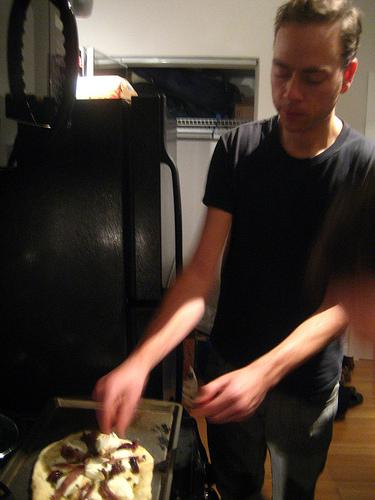Identify the color of the fridge and where it is located in relation to the man. The fridge is black and it is located besides the man. Can you list three distinct features of the man's face? The man has a visible nose, mouth, and eyebrows. Explain the position and color of the tray. The tray is grey in color and is located in the stove. Analyze the interaction between the man and the objects around him. The man is actively preparing food, possibly using the stove, with a fridge and other objects nearby, suggesting he is engaging with his kitchen environment. What is the color of the floor and what are the knobs' color? The floor is brown, and the knobs are black. How does the image make you feel, and why? The image feels warm and familiar, as it shows a typical daily activity of someone preparing food in their kitchen. What is the man in the image wearing and what is he doing? The man is wearing a black shirt and black jeans and he is preparing food. Provide a general description of the setting of the image. The scene is set in a kitchen with a black fridge, a man preparing food, a grey tray in the stove, and a mirror on the wall. Estimate the number of objects that can be counted in the image. There are at least 10 objects that can be counted in the image. Determine the quality of the image based on the provided information. The image seems to be high in detail with precise object positions and sizes, indicating a high-quality image. Locate the green plant beside the mirror and note its size in width and height. There is no mention of a plant in the image, nor any information related to its color, position, or size. Requesting the user to pay attention to such a detail is misleading, as it does not exist. Get the proportions of the blue couch positioned near the wall. The image details provided do not specify any couch, blue or otherwise. By asking the user to find the measurements of the couch, the instruction is misleading because it is about a non-existent object. Can you please point out the pink umbrella in the image? There is no mention of an umbrella in the given information or any object related to it. The instruction is misleading as it asks the user to identify a non-existent object. Notice the orange cat resting on the floor, find its position in (X, Y) coordinates. The given information does not mention any cat present in the image. Asking the user to locate the coordinates of an animal is misleading since it does not exist in the scene. Where is the red coffee mug placed on the tray, and what are its dimensions? None of the objects mentioned in the image information include a coffee mug. The question is misleading because it asks the user to locate a non-existent object and determine its dimensions. Identify the yellow clock hanging on the wall and provide its size (Width, Height). There is no mention of a clock in the image's details, let alone one of a specific color. This instruction misleads the user by directing them to find the size of an object that is not present in the image. 